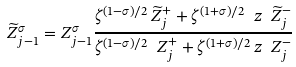Convert formula to latex. <formula><loc_0><loc_0><loc_500><loc_500>\widetilde { Z } _ { j - 1 } ^ { \sigma } = { Z } _ { j - 1 } ^ { \sigma } \frac { \zeta ^ { ( 1 - \sigma ) / 2 } \, \widetilde { Z } _ { j } ^ { + } + \zeta ^ { ( 1 + \sigma ) / 2 } \ z \ \widetilde { Z } _ { j } ^ { - } } { \zeta ^ { ( 1 - \sigma ) / 2 } \ { Z } _ { j } ^ { + } + \zeta ^ { ( 1 + \sigma ) / 2 } \, z \ { Z } _ { j } ^ { - } } \,</formula> 